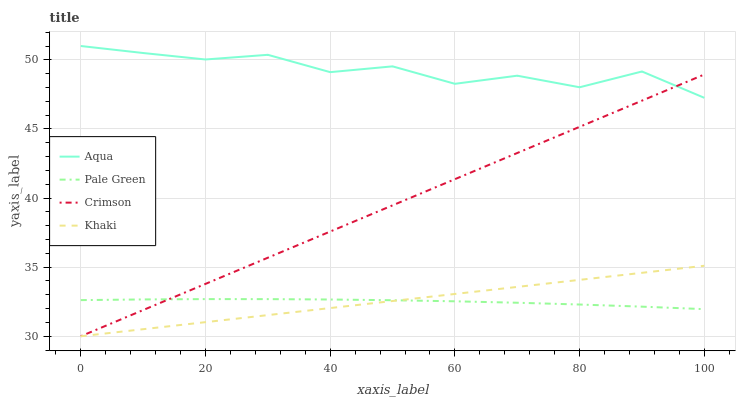Does Pale Green have the minimum area under the curve?
Answer yes or no. Yes. Does Aqua have the minimum area under the curve?
Answer yes or no. No. Does Pale Green have the maximum area under the curve?
Answer yes or no. No. Is Pale Green the smoothest?
Answer yes or no. No. Is Pale Green the roughest?
Answer yes or no. No. Does Pale Green have the lowest value?
Answer yes or no. No. Does Pale Green have the highest value?
Answer yes or no. No. Is Khaki less than Aqua?
Answer yes or no. Yes. Is Aqua greater than Khaki?
Answer yes or no. Yes. Does Khaki intersect Aqua?
Answer yes or no. No. 